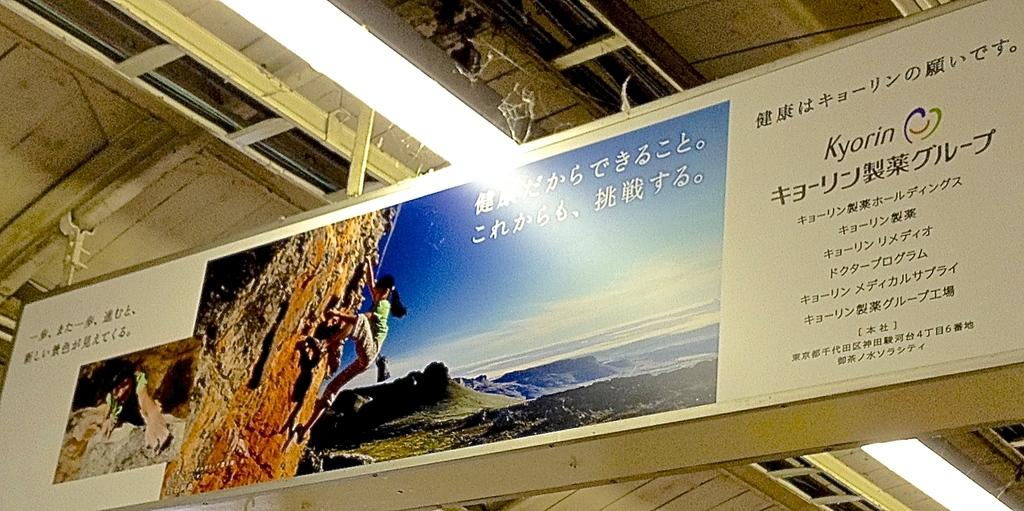<image>
Give a short and clear explanation of the subsequent image. While in Kyorin you can climb the mountains. 